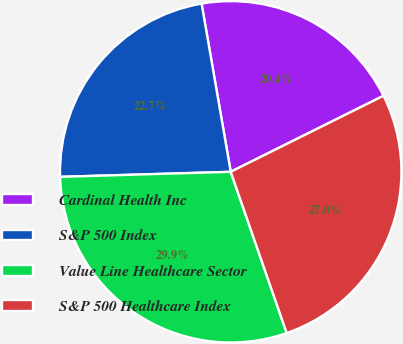Convert chart. <chart><loc_0><loc_0><loc_500><loc_500><pie_chart><fcel>Cardinal Health Inc<fcel>S&P 500 Index<fcel>Value Line Healthcare Sector<fcel>S&P 500 Healthcare Index<nl><fcel>20.38%<fcel>22.74%<fcel>29.85%<fcel>27.03%<nl></chart> 